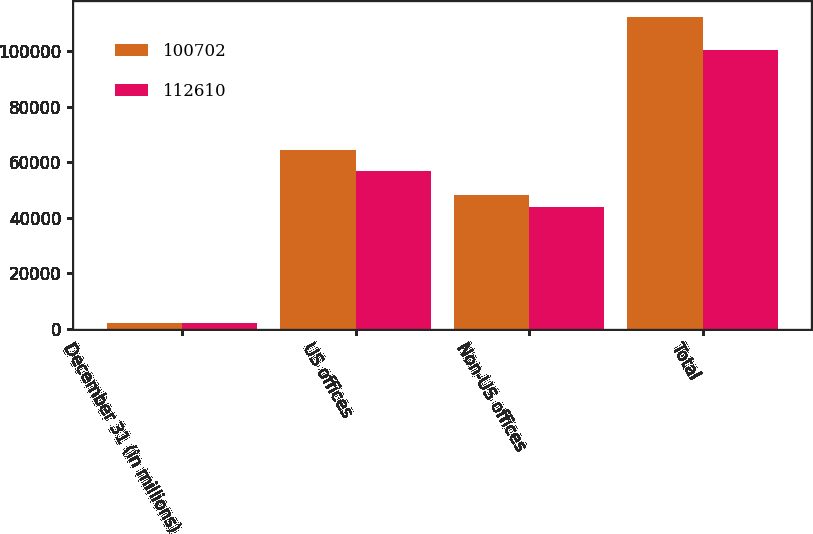Convert chart to OTSL. <chart><loc_0><loc_0><loc_500><loc_500><stacked_bar_chart><ecel><fcel>December 31 (in millions)<fcel>US offices<fcel>Non-US offices<fcel>Total<nl><fcel>100702<fcel>2015<fcel>64519<fcel>48091<fcel>112610<nl><fcel>112610<fcel>2014<fcel>56983<fcel>43719<fcel>100702<nl></chart> 